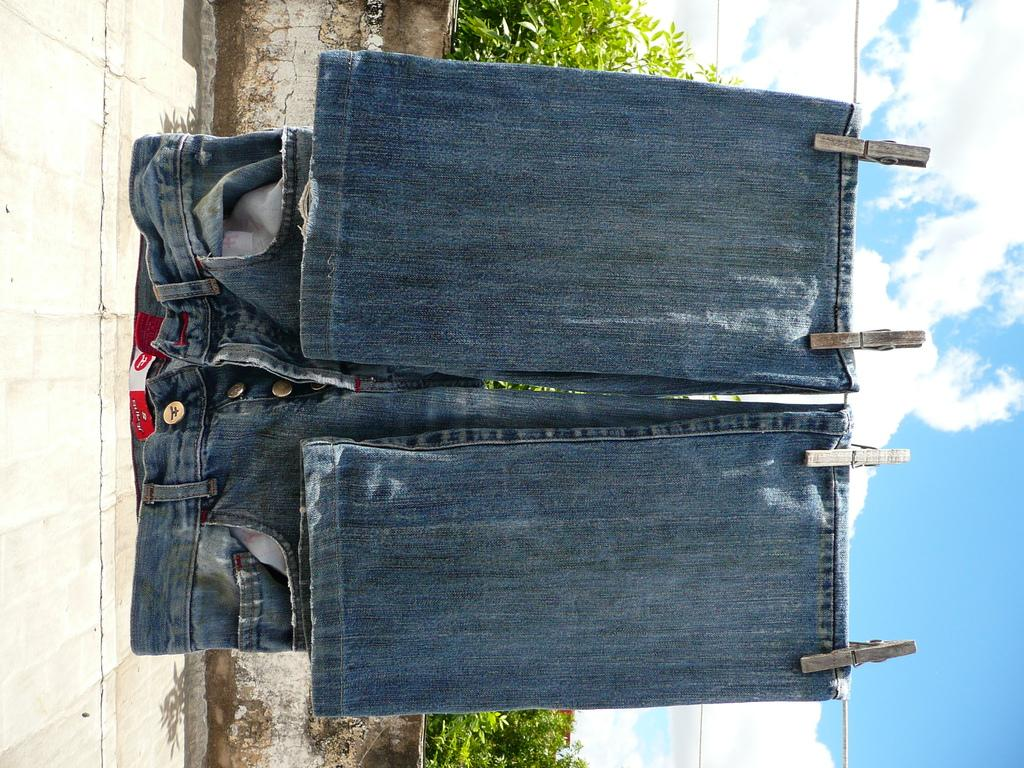What type of clothing is hanging in the image? There is a jeans pant hanging in the image. How is the jeans pant being supported in the image? The jeans pant is hanging from a rope. What is the orientation of the image? The image is vertical. What can be seen in the background of the image? There are plants and the sky visible in the image. What is the condition of the sky in the image? Clouds are present in the sky. How many balls are being used as a reward for the rock in the image? There are no balls or rocks present in the image. 